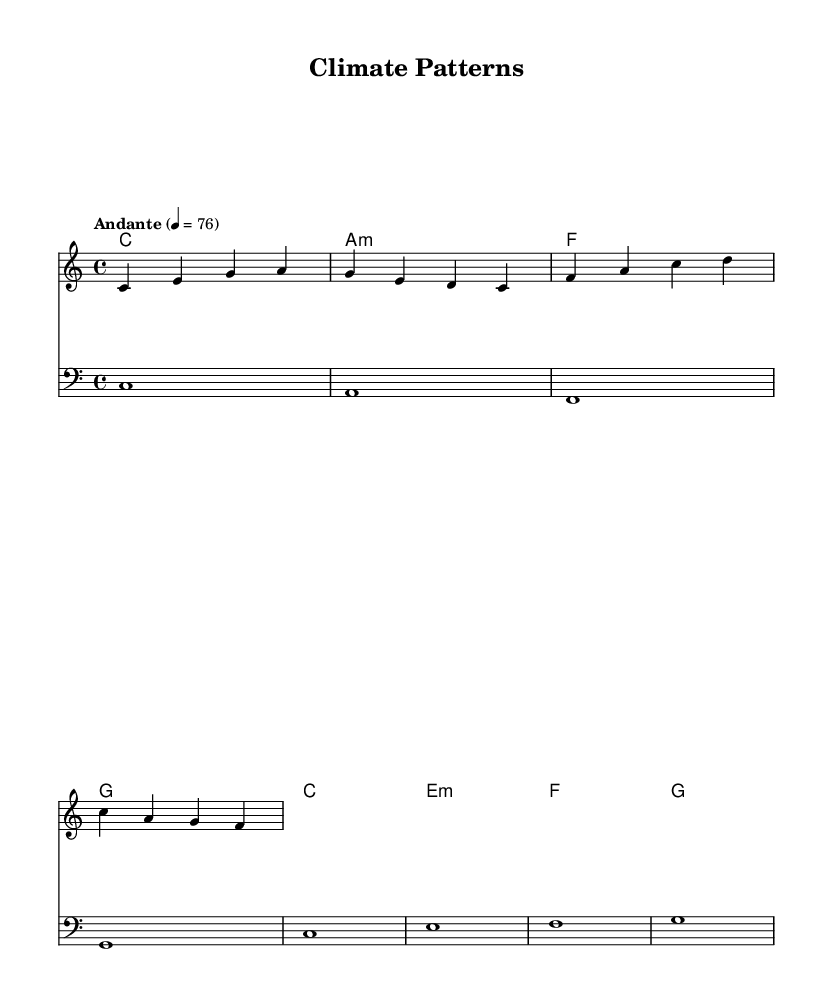What is the key signature of this music? The key signature is C major, which indicates that there are no sharps or flats in the piece, and it can be found at the beginning of the staff.
Answer: C major What is the time signature of this piece? The time signature shown at the beginning of the music is 4/4, meaning there are four beats in each measure, and the quarter note gets one beat.
Answer: 4/4 What is the tempo marking? The tempo marking is "Andante," which indicates a moderately slow pace, and the number 76 indicates the beats per minute (BPM).
Answer: Andante How many measures are in the melody section? The melody section consists of four measures, as indicated by the vertical lines (bar lines) separating the groupings of notes.
Answer: 4 What is the highest note in the melody? The highest note in the melody is the note A, which is found in the first measure.
Answer: A Which chord appears first in the harmony section? The first chord in the harmony section is C major, identified by the chord symbol written above the staff at the beginning.
Answer: C What is the role of the bass clef in this piece? The bass clef indicates that the notes written in that staff are played with a lower range, typically by bass instruments, providing harmonic support and depth to the music.
Answer: Lower range 